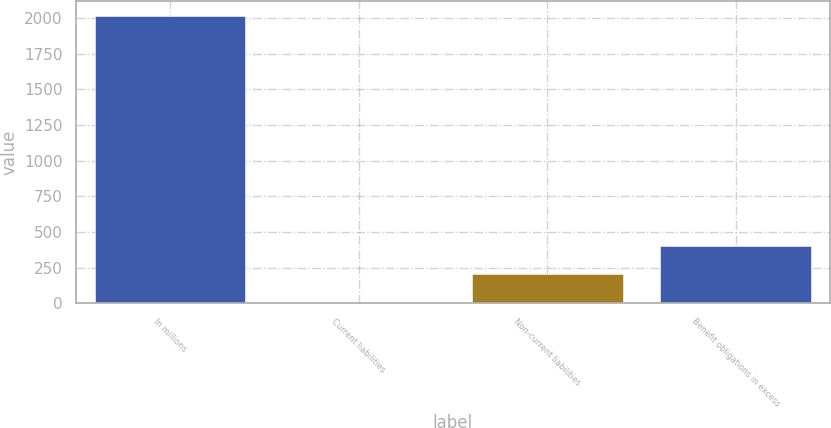Convert chart. <chart><loc_0><loc_0><loc_500><loc_500><bar_chart><fcel>In millions<fcel>Current liabilities<fcel>Non-current liabilities<fcel>Benefit obligations in excess<nl><fcel>2017<fcel>3.1<fcel>204.49<fcel>405.88<nl></chart> 